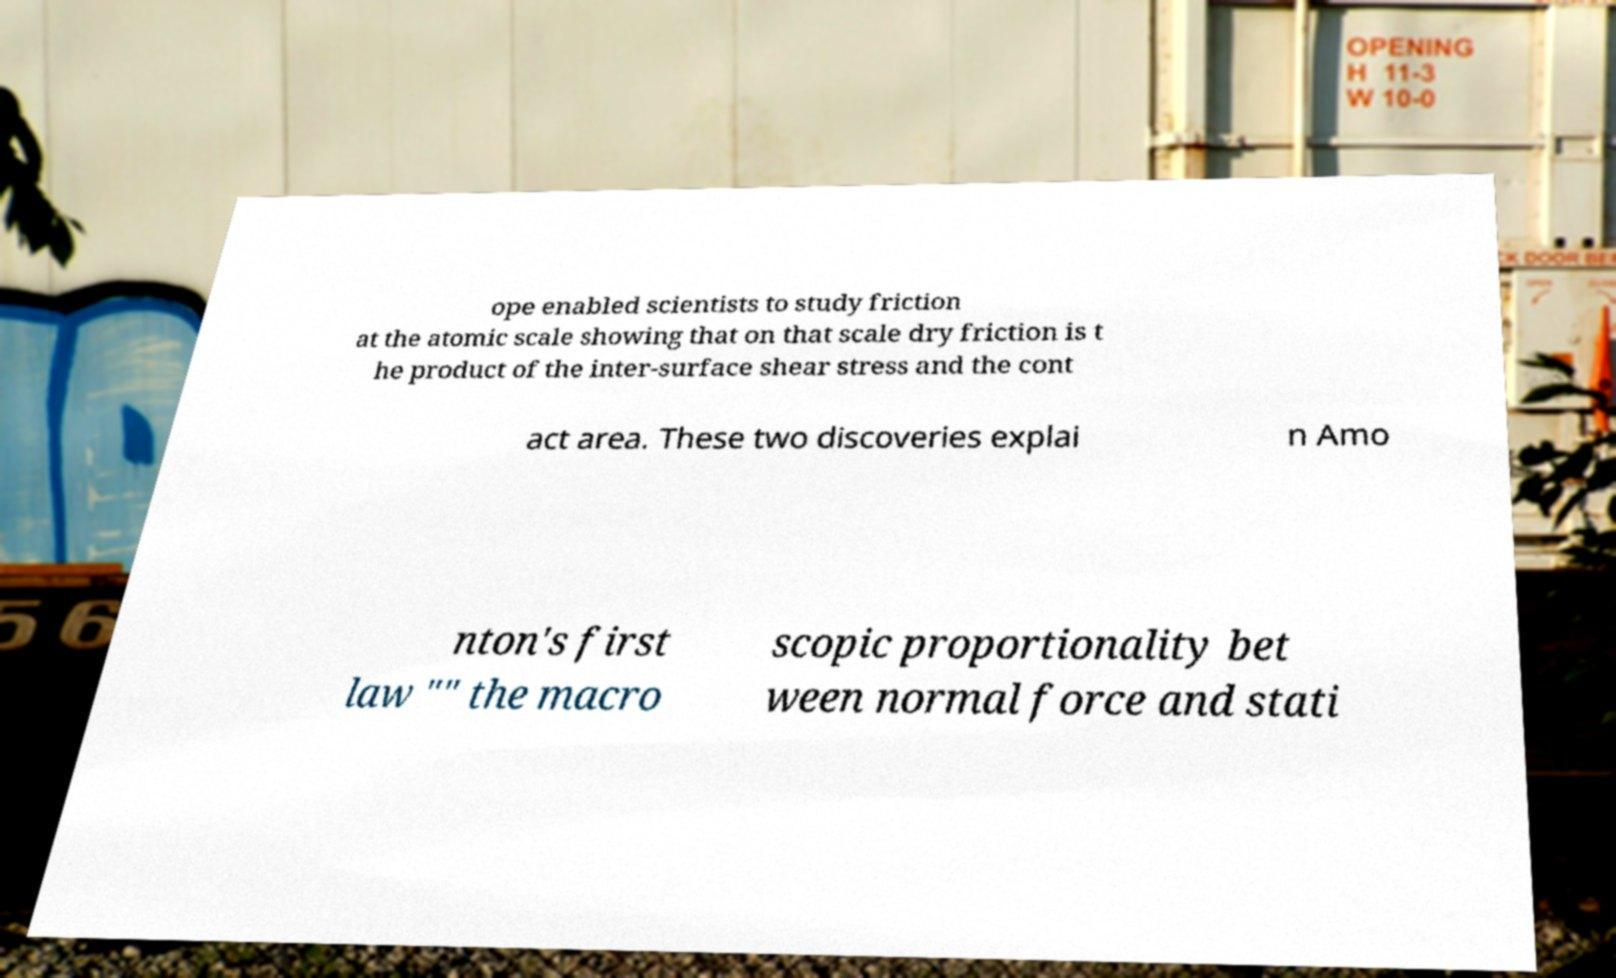Please read and relay the text visible in this image. What does it say? ope enabled scientists to study friction at the atomic scale showing that on that scale dry friction is t he product of the inter-surface shear stress and the cont act area. These two discoveries explai n Amo nton's first law "" the macro scopic proportionality bet ween normal force and stati 